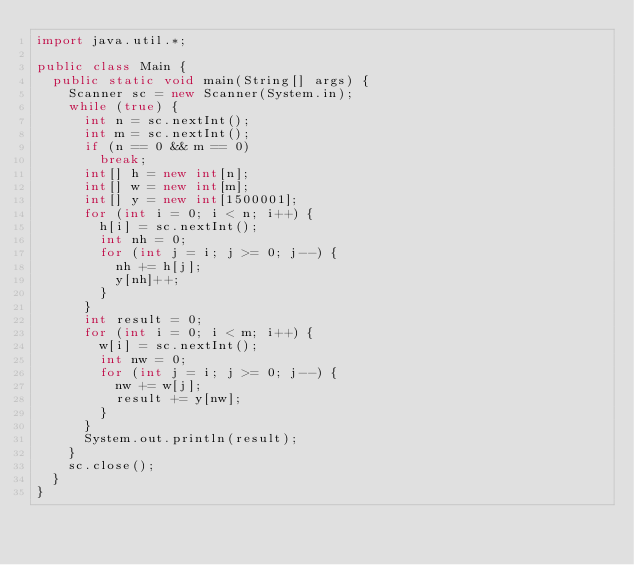<code> <loc_0><loc_0><loc_500><loc_500><_Java_>import java.util.*;

public class Main {
	public static void main(String[] args) {
		Scanner sc = new Scanner(System.in);
		while (true) {
			int n = sc.nextInt();
			int m = sc.nextInt();
			if (n == 0 && m == 0)
				break;
			int[] h = new int[n];
			int[] w = new int[m];
			int[] y = new int[1500001];
			for (int i = 0; i < n; i++) {
				h[i] = sc.nextInt();
				int nh = 0;
				for (int j = i; j >= 0; j--) {
					nh += h[j];
					y[nh]++;
				}
			}
			int result = 0;
			for (int i = 0; i < m; i++) {
				w[i] = sc.nextInt();
				int nw = 0;
				for (int j = i; j >= 0; j--) {
					nw += w[j];
					result += y[nw];
				}
			}
			System.out.println(result);
		}
		sc.close();
	}
}</code> 